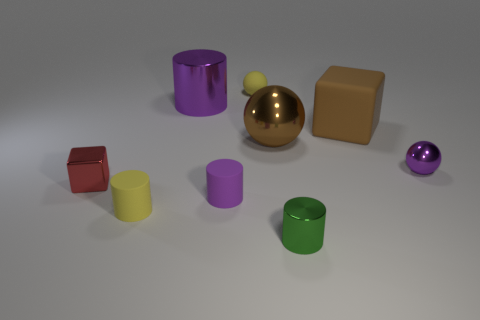Add 1 tiny metal cylinders. How many objects exist? 10 Subtract all cylinders. How many objects are left? 5 Subtract all matte things. Subtract all shiny spheres. How many objects are left? 3 Add 3 yellow balls. How many yellow balls are left? 4 Add 4 shiny cylinders. How many shiny cylinders exist? 6 Subtract 0 red cylinders. How many objects are left? 9 